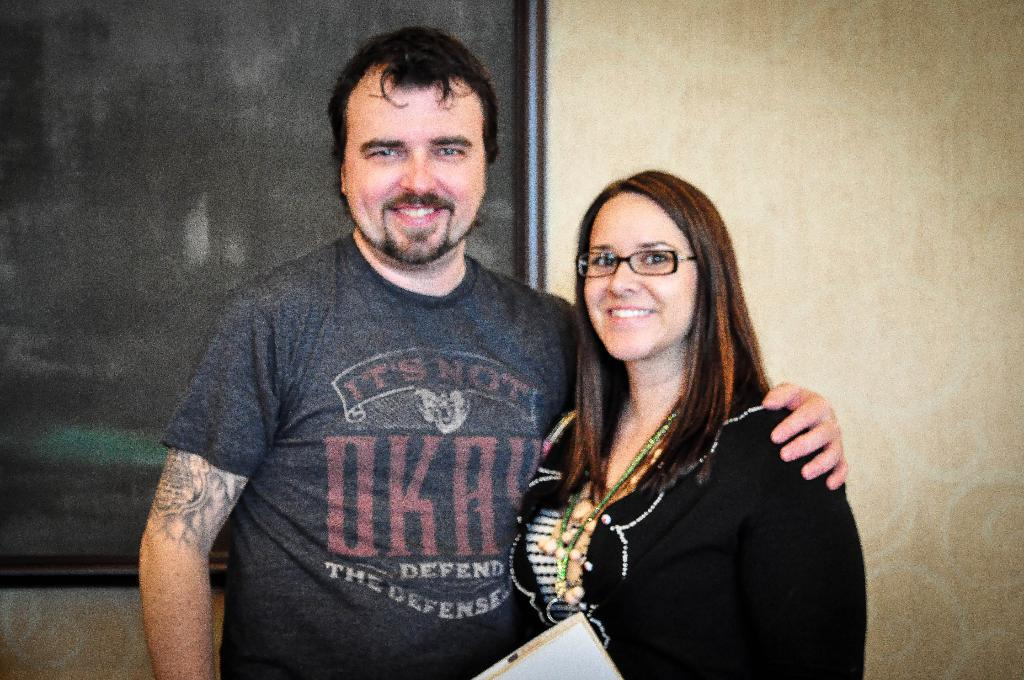What are the people in the image doing? The people in the image are standing and smiling. Can you describe any specific features of the people? One person is wearing glasses. What is the person holding in the image? One person is holding an object. What can be seen in the background of the image? There is a board and a wall in the background of the image. What type of fear can be seen on the person's face in the image? There is no fear visible on anyone's face in the image; the people are smiling. How many ducks are present in the image? There are no ducks present in the image. 